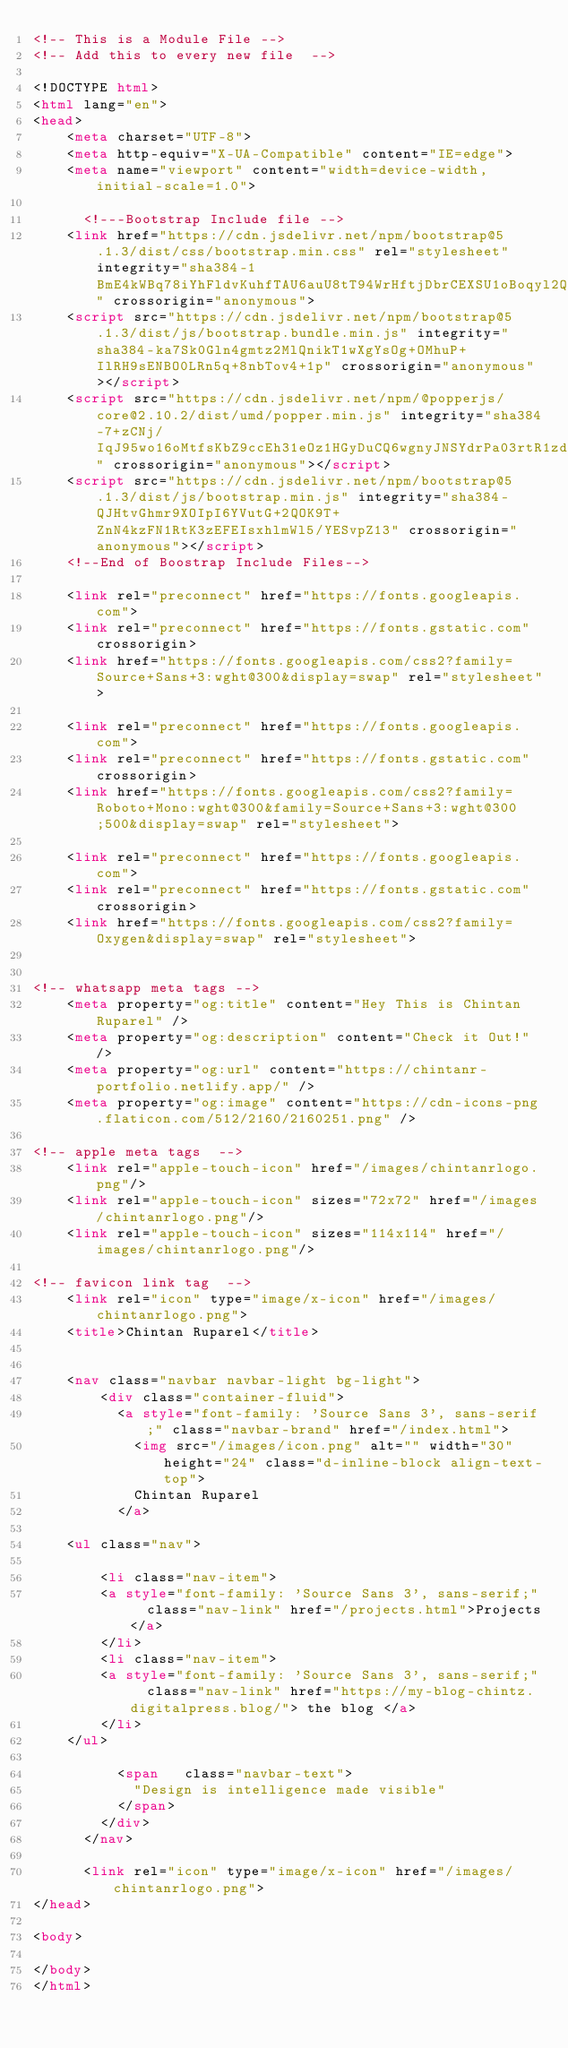<code> <loc_0><loc_0><loc_500><loc_500><_HTML_><!-- This is a Module File -->
<!-- Add this to every new file  -->

<!DOCTYPE html>
<html lang="en">
<head>
    <meta charset="UTF-8">
    <meta http-equiv="X-UA-Compatible" content="IE=edge">
    <meta name="viewport" content="width=device-width, initial-scale=1.0">

      <!---Bootstrap Include file -->
    <link href="https://cdn.jsdelivr.net/npm/bootstrap@5.1.3/dist/css/bootstrap.min.css" rel="stylesheet" integrity="sha384-1BmE4kWBq78iYhFldvKuhfTAU6auU8tT94WrHftjDbrCEXSU1oBoqyl2QvZ6jIW3" crossorigin="anonymous">
    <script src="https://cdn.jsdelivr.net/npm/bootstrap@5.1.3/dist/js/bootstrap.bundle.min.js" integrity="sha384-ka7Sk0Gln4gmtz2MlQnikT1wXgYsOg+OMhuP+IlRH9sENBO0LRn5q+8nbTov4+1p" crossorigin="anonymous"></script>
    <script src="https://cdn.jsdelivr.net/npm/@popperjs/core@2.10.2/dist/umd/popper.min.js" integrity="sha384-7+zCNj/IqJ95wo16oMtfsKbZ9ccEh31eOz1HGyDuCQ6wgnyJNSYdrPa03rtR1zdB" crossorigin="anonymous"></script>
    <script src="https://cdn.jsdelivr.net/npm/bootstrap@5.1.3/dist/js/bootstrap.min.js" integrity="sha384-QJHtvGhmr9XOIpI6YVutG+2QOK9T+ZnN4kzFN1RtK3zEFEIsxhlmWl5/YESvpZ13" crossorigin="anonymous"></script>
    <!--End of Boostrap Include Files-->

    <link rel="preconnect" href="https://fonts.googleapis.com"> 
    <link rel="preconnect" href="https://fonts.gstatic.com" crossorigin> 
    <link href="https://fonts.googleapis.com/css2?family=Source+Sans+3:wght@300&display=swap" rel="stylesheet">

    <link rel="preconnect" href="https://fonts.googleapis.com"> 
    <link rel="preconnect" href="https://fonts.gstatic.com" crossorigin> 
    <link href="https://fonts.googleapis.com/css2?family=Roboto+Mono:wght@300&family=Source+Sans+3:wght@300;500&display=swap" rel="stylesheet">

    <link rel="preconnect" href="https://fonts.googleapis.com"> 
    <link rel="preconnect" href="https://fonts.gstatic.com" crossorigin> 
    <link href="https://fonts.googleapis.com/css2?family=Oxygen&display=swap" rel="stylesheet">


<!-- whatsapp meta tags -->
    <meta property="og:title" content="Hey This is Chintan Ruparel" />
    <meta property="og:description" content="Check it Out!" />
    <meta property="og:url" content="https://chintanr-portfolio.netlify.app/" />
    <meta property="og:image" content="https://cdn-icons-png.flaticon.com/512/2160/2160251.png" />

<!-- apple meta tags  -->
    <link rel="apple-touch-icon" href="/images/chintanrlogo.png"/>
    <link rel="apple-touch-icon" sizes="72x72" href="/images/chintanrlogo.png"/>
    <link rel="apple-touch-icon" sizes="114x114" href="/images/chintanrlogo.png"/>   
    
<!-- favicon link tag  -->
    <link rel="icon" type="image/x-icon" href="/images/chintanrlogo.png">
    <title>Chintan Ruparel</title>


    <nav class="navbar navbar-light bg-light">
        <div class="container-fluid">
          <a style="font-family: 'Source Sans 3', sans-serif;" class="navbar-brand" href="/index.html">
            <img src="/images/icon.png" alt="" width="30" height="24" class="d-inline-block align-text-top">
            Chintan Ruparel 
          </a>
          
    <ul class="nav">

        <li class="nav-item">
        <a style="font-family: 'Source Sans 3', sans-serif;"  class="nav-link" href="/projects.html">Projects</a>
        </li>
        <li class="nav-item">
        <a style="font-family: 'Source Sans 3', sans-serif;"  class="nav-link" href="https://my-blog-chintz.digitalpress.blog/"> the blog </a>
        </li>
    </ul>

          <span   class="navbar-text">
            "Design is intelligence made visible"
          </span>
        </div>
      </nav>

      <link rel="icon" type="image/x-icon" href="/images/chintanrlogo.png">
</head>

<body>

</body>
</html></code> 